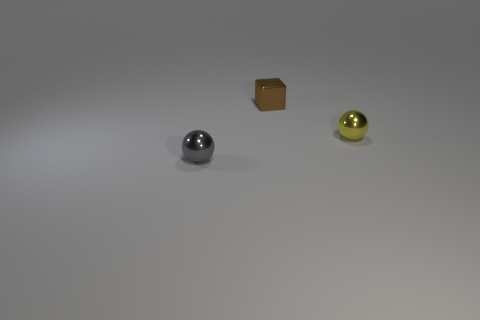Subtract 0 gray cylinders. How many objects are left? 3 Subtract all balls. How many objects are left? 1 Subtract 2 spheres. How many spheres are left? 0 Subtract all green cubes. Subtract all blue cylinders. How many cubes are left? 1 Subtract all green spheres. How many gray cubes are left? 0 Subtract all cyan metallic cylinders. Subtract all gray objects. How many objects are left? 2 Add 3 yellow things. How many yellow things are left? 4 Add 2 big red shiny spheres. How many big red shiny spheres exist? 2 Add 3 small yellow spheres. How many objects exist? 6 Subtract all yellow spheres. How many spheres are left? 1 